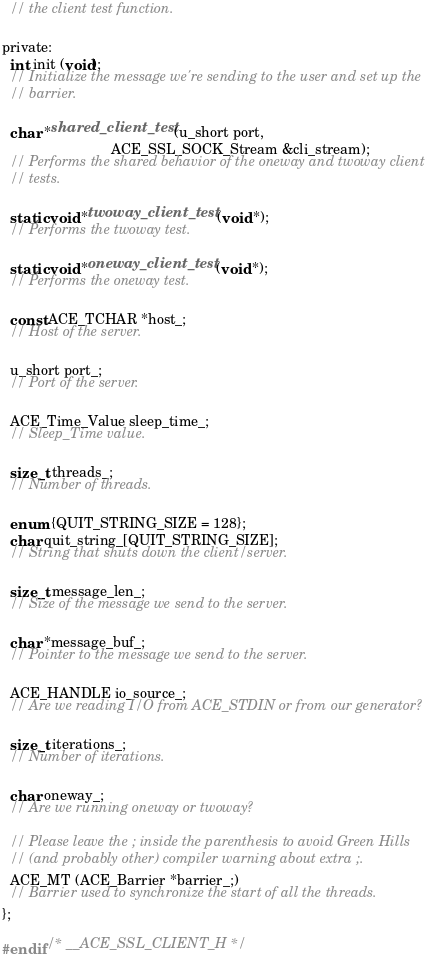Convert code to text. <code><loc_0><loc_0><loc_500><loc_500><_C_>  // the client test function.

private:
  int init (void);
  // Initialize the message we're sending to the user and set up the
  // barrier.

  char *shared_client_test (u_short port,
                            ACE_SSL_SOCK_Stream &cli_stream);
  // Performs the shared behavior of the oneway and twoway client
  // tests.

  static void *twoway_client_test (void *);
  // Performs the twoway test.

  static void *oneway_client_test (void *);
  // Performs the oneway test.

  const ACE_TCHAR *host_;
  // Host of the server.

  u_short port_;
  // Port of the server.

  ACE_Time_Value sleep_time_;
  // Sleep_Time value.

  size_t threads_;
  // Number of threads.

  enum {QUIT_STRING_SIZE = 128};
  char quit_string_[QUIT_STRING_SIZE];
  // String that shuts down the client/server.

  size_t message_len_;
  // Size of the message we send to the server.

  char *message_buf_;
  // Pointer to the message we send to the server.

  ACE_HANDLE io_source_;
  // Are we reading I/O from ACE_STDIN or from our generator?

  size_t iterations_;
  // Number of iterations.

  char oneway_;
  // Are we running oneway or twoway?

  // Please leave the ; inside the parenthesis to avoid Green Hills
  // (and probably other) compiler warning about extra ;.
  ACE_MT (ACE_Barrier *barrier_;)
  // Barrier used to synchronize the start of all the threads.
};

#endif /* __ACE_SSL_CLIENT_H */
</code> 